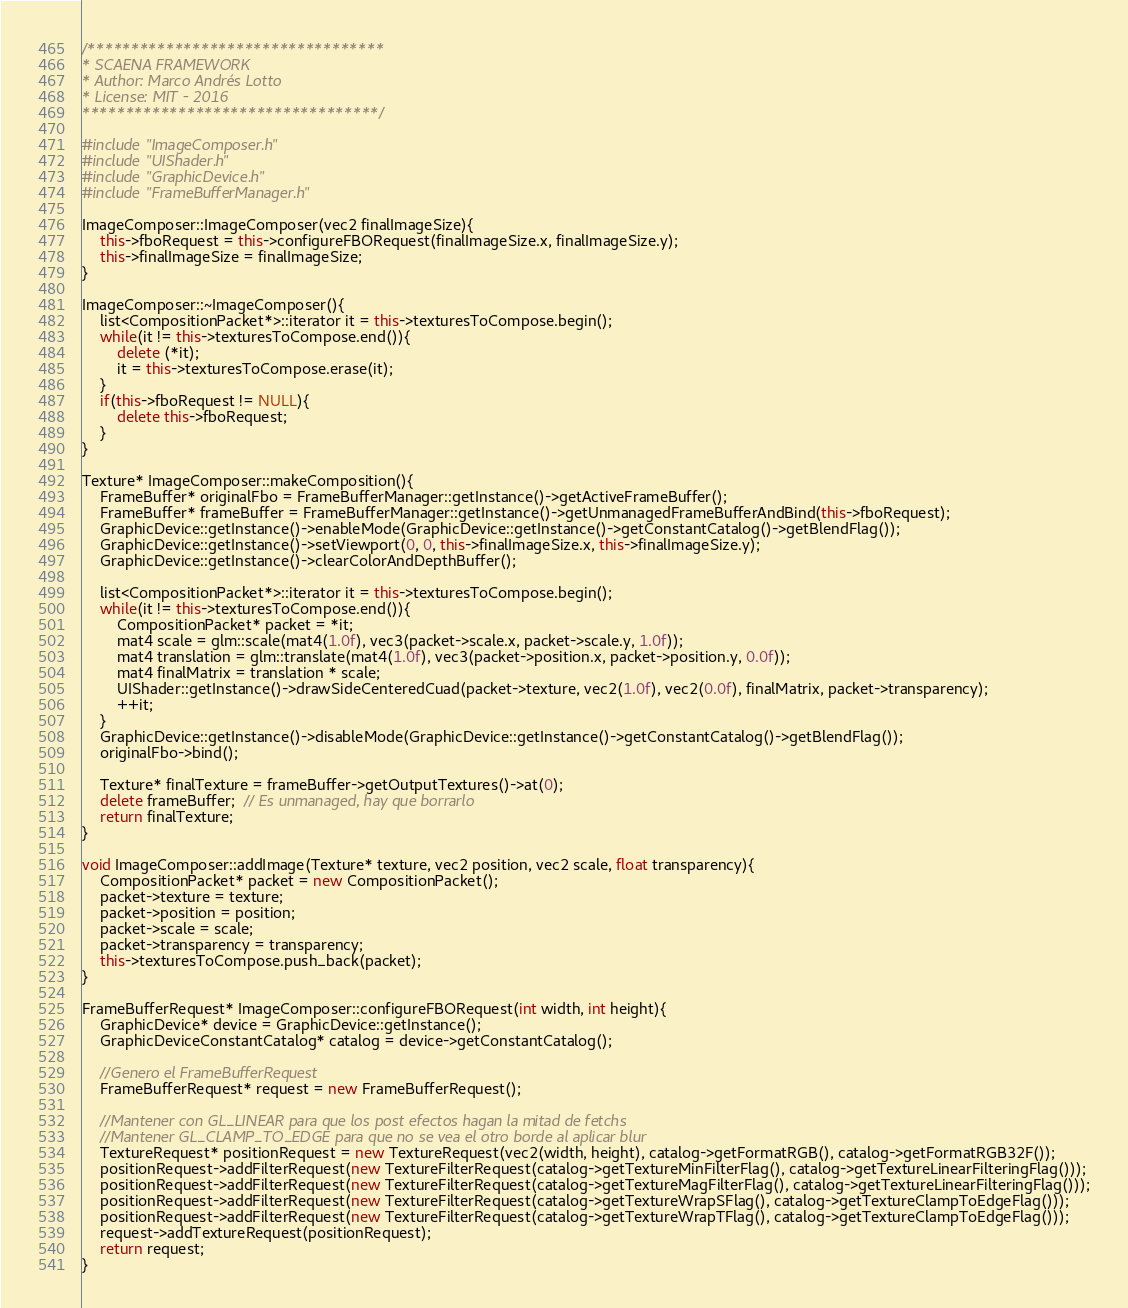<code> <loc_0><loc_0><loc_500><loc_500><_C++_>/**********************************
* SCAENA FRAMEWORK
* Author: Marco Andrés Lotto
* License: MIT - 2016
**********************************/

#include "ImageComposer.h"
#include "UIShader.h"
#include "GraphicDevice.h"
#include "FrameBufferManager.h"

ImageComposer::ImageComposer(vec2 finalImageSize){
	this->fboRequest = this->configureFBORequest(finalImageSize.x, finalImageSize.y);
	this->finalImageSize = finalImageSize;
}

ImageComposer::~ImageComposer(){
	list<CompositionPacket*>::iterator it = this->texturesToCompose.begin();
	while(it != this->texturesToCompose.end()){
		delete (*it);
		it = this->texturesToCompose.erase(it);
	}
	if(this->fboRequest != NULL){
		delete this->fboRequest;
	}
}
	
Texture* ImageComposer::makeComposition(){	
	FrameBuffer* originalFbo = FrameBufferManager::getInstance()->getActiveFrameBuffer();
	FrameBuffer* frameBuffer = FrameBufferManager::getInstance()->getUnmanagedFrameBufferAndBind(this->fboRequest);
	GraphicDevice::getInstance()->enableMode(GraphicDevice::getInstance()->getConstantCatalog()->getBlendFlag());	
	GraphicDevice::getInstance()->setViewport(0, 0, this->finalImageSize.x, this->finalImageSize.y);
	GraphicDevice::getInstance()->clearColorAndDepthBuffer();

	list<CompositionPacket*>::iterator it = this->texturesToCompose.begin();
	while(it != this->texturesToCompose.end()){
		CompositionPacket* packet = *it;
		mat4 scale = glm::scale(mat4(1.0f), vec3(packet->scale.x, packet->scale.y, 1.0f));
		mat4 translation = glm::translate(mat4(1.0f), vec3(packet->position.x, packet->position.y, 0.0f));
		mat4 finalMatrix = translation * scale;
		UIShader::getInstance()->drawSideCenteredCuad(packet->texture, vec2(1.0f), vec2(0.0f), finalMatrix, packet->transparency);	
		++it;
	}
	GraphicDevice::getInstance()->disableMode(GraphicDevice::getInstance()->getConstantCatalog()->getBlendFlag());	
	originalFbo->bind();

	Texture* finalTexture = frameBuffer->getOutputTextures()->at(0);
	delete frameBuffer;  // Es unmanaged, hay que borrarlo
	return finalTexture;
}

void ImageComposer::addImage(Texture* texture, vec2 position, vec2 scale, float transparency){
	CompositionPacket* packet = new CompositionPacket();
	packet->texture = texture;
	packet->position = position;
	packet->scale = scale;
	packet->transparency = transparency;
	this->texturesToCompose.push_back(packet);
}

FrameBufferRequest* ImageComposer::configureFBORequest(int width, int height){
	GraphicDevice* device = GraphicDevice::getInstance();
	GraphicDeviceConstantCatalog* catalog = device->getConstantCatalog();

	//Genero el FrameBufferRequest
	FrameBufferRequest* request = new FrameBufferRequest();
	
	//Mantener con GL_LINEAR para que los post efectos hagan la mitad de fetchs
	//Mantener GL_CLAMP_TO_EDGE para que no se vea el otro borde al aplicar blur
	TextureRequest* positionRequest = new TextureRequest(vec2(width, height), catalog->getFormatRGB(), catalog->getFormatRGB32F());
	positionRequest->addFilterRequest(new TextureFilterRequest(catalog->getTextureMinFilterFlag(), catalog->getTextureLinearFilteringFlag()));
	positionRequest->addFilterRequest(new TextureFilterRequest(catalog->getTextureMagFilterFlag(), catalog->getTextureLinearFilteringFlag()));
	positionRequest->addFilterRequest(new TextureFilterRequest(catalog->getTextureWrapSFlag(), catalog->getTextureClampToEdgeFlag()));
	positionRequest->addFilterRequest(new TextureFilterRequest(catalog->getTextureWrapTFlag(), catalog->getTextureClampToEdgeFlag()));
	request->addTextureRequest(positionRequest);
	return request;
}</code> 